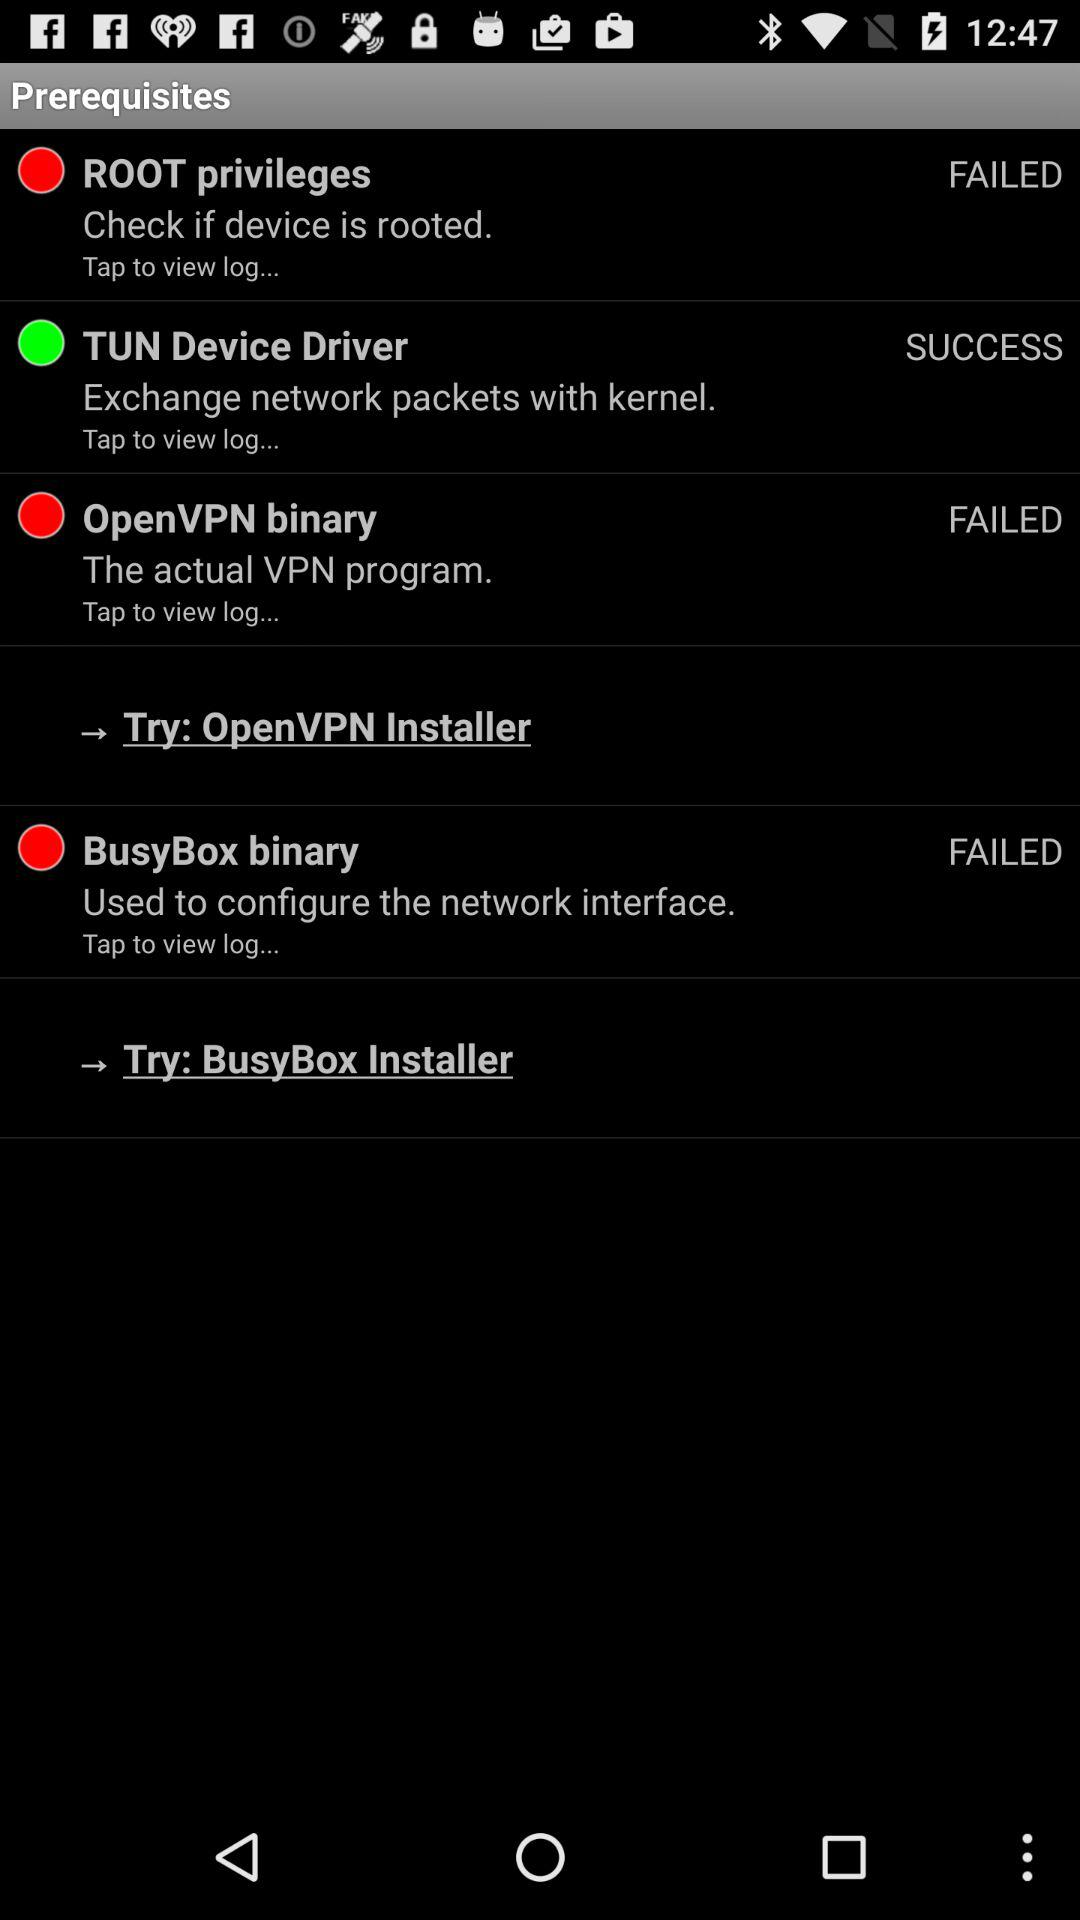Are the "ROOT privileges" failed or successful? The "ROOTS privileges" have failed. 